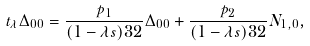Convert formula to latex. <formula><loc_0><loc_0><loc_500><loc_500>t _ { \lambda } \Delta _ { 0 0 } = \frac { p _ { 1 } } { ( 1 - \lambda s ) ^ { } { 3 } 2 } \Delta _ { 0 0 } + \frac { p _ { 2 } } { ( 1 - \lambda s ) ^ { } { 3 } 2 } N _ { 1 , 0 } ,</formula> 